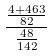<formula> <loc_0><loc_0><loc_500><loc_500>\frac { \frac { 4 + 4 6 3 } { 8 2 } } { \frac { 4 8 } { 1 4 2 } }</formula> 